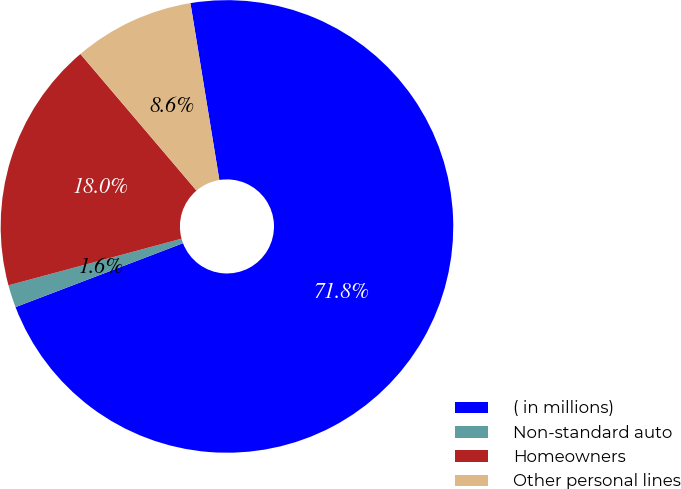Convert chart. <chart><loc_0><loc_0><loc_500><loc_500><pie_chart><fcel>( in millions)<fcel>Non-standard auto<fcel>Homeowners<fcel>Other personal lines<nl><fcel>71.78%<fcel>1.61%<fcel>17.98%<fcel>8.63%<nl></chart> 